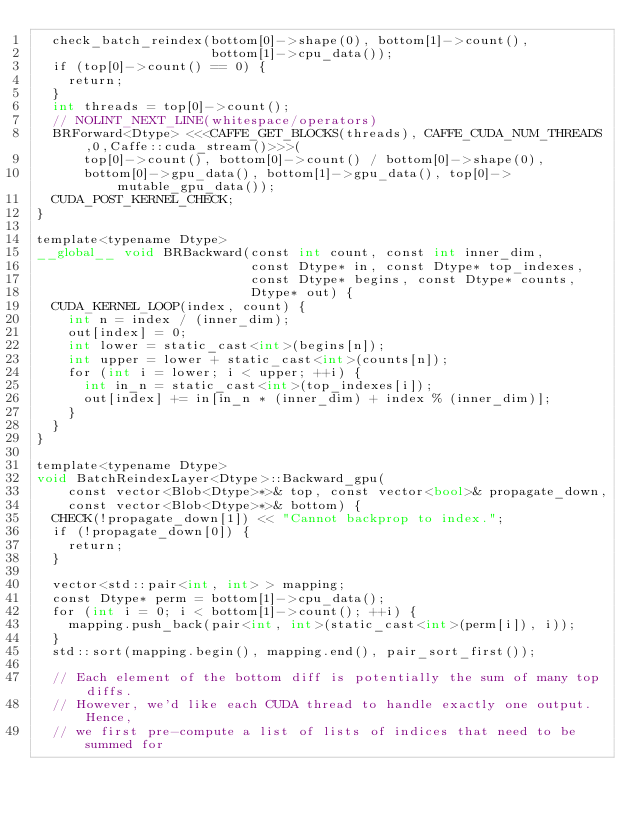Convert code to text. <code><loc_0><loc_0><loc_500><loc_500><_Cuda_>  check_batch_reindex(bottom[0]->shape(0), bottom[1]->count(),
                      bottom[1]->cpu_data());
  if (top[0]->count() == 0) {
    return;
  }
  int threads = top[0]->count();
  // NOLINT_NEXT_LINE(whitespace/operators)
  BRForward<Dtype> <<<CAFFE_GET_BLOCKS(threads), CAFFE_CUDA_NUM_THREADS,0,Caffe::cuda_stream()>>>(
      top[0]->count(), bottom[0]->count() / bottom[0]->shape(0),
      bottom[0]->gpu_data(), bottom[1]->gpu_data(), top[0]->mutable_gpu_data());
  CUDA_POST_KERNEL_CHECK;
}

template<typename Dtype>
__global__ void BRBackward(const int count, const int inner_dim,
                           const Dtype* in, const Dtype* top_indexes,
                           const Dtype* begins, const Dtype* counts,
                           Dtype* out) {
  CUDA_KERNEL_LOOP(index, count) {
    int n = index / (inner_dim);
    out[index] = 0;
    int lower = static_cast<int>(begins[n]);
    int upper = lower + static_cast<int>(counts[n]);
    for (int i = lower; i < upper; ++i) {
      int in_n = static_cast<int>(top_indexes[i]);
      out[index] += in[in_n * (inner_dim) + index % (inner_dim)];
    }
  }
}

template<typename Dtype>
void BatchReindexLayer<Dtype>::Backward_gpu(
    const vector<Blob<Dtype>*>& top, const vector<bool>& propagate_down,
    const vector<Blob<Dtype>*>& bottom) {
  CHECK(!propagate_down[1]) << "Cannot backprop to index.";
  if (!propagate_down[0]) {
    return;
  }

  vector<std::pair<int, int> > mapping;
  const Dtype* perm = bottom[1]->cpu_data();
  for (int i = 0; i < bottom[1]->count(); ++i) {
    mapping.push_back(pair<int, int>(static_cast<int>(perm[i]), i));
  }
  std::sort(mapping.begin(), mapping.end(), pair_sort_first());

  // Each element of the bottom diff is potentially the sum of many top diffs.
  // However, we'd like each CUDA thread to handle exactly one output.  Hence,
  // we first pre-compute a list of lists of indices that need to be summed for</code> 